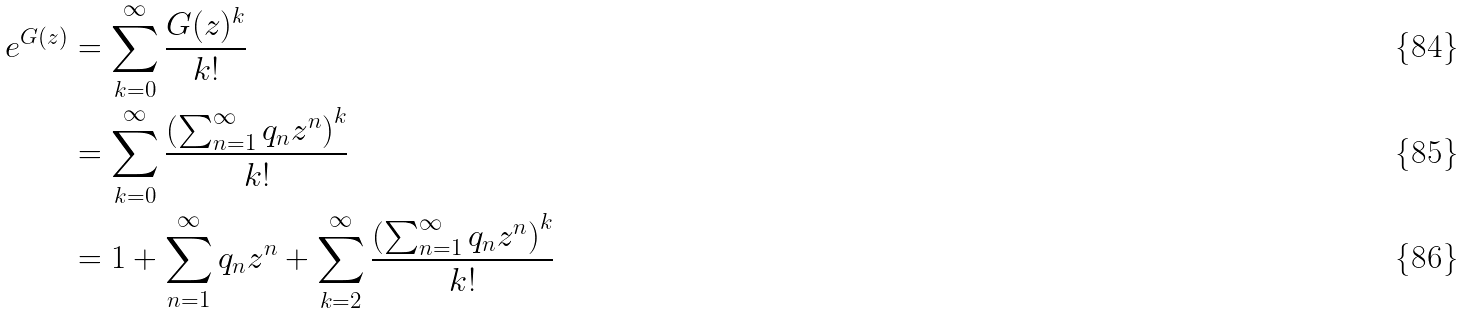<formula> <loc_0><loc_0><loc_500><loc_500>e ^ { G ( z ) } & = \sum _ { k = 0 } ^ { \infty } \frac { G ( z ) ^ { k } } { k ! } \\ & = \sum _ { k = 0 } ^ { \infty } \frac { \left ( \sum _ { n = 1 } ^ { \infty } q _ { n } z ^ { n } \right ) ^ { k } } { k ! } \\ & = 1 + \sum _ { n = 1 } ^ { \infty } q _ { n } z ^ { n } + \sum _ { k = 2 } ^ { \infty } \frac { \left ( \sum _ { n = 1 } ^ { \infty } q _ { n } z ^ { n } \right ) ^ { k } } { k ! }</formula> 